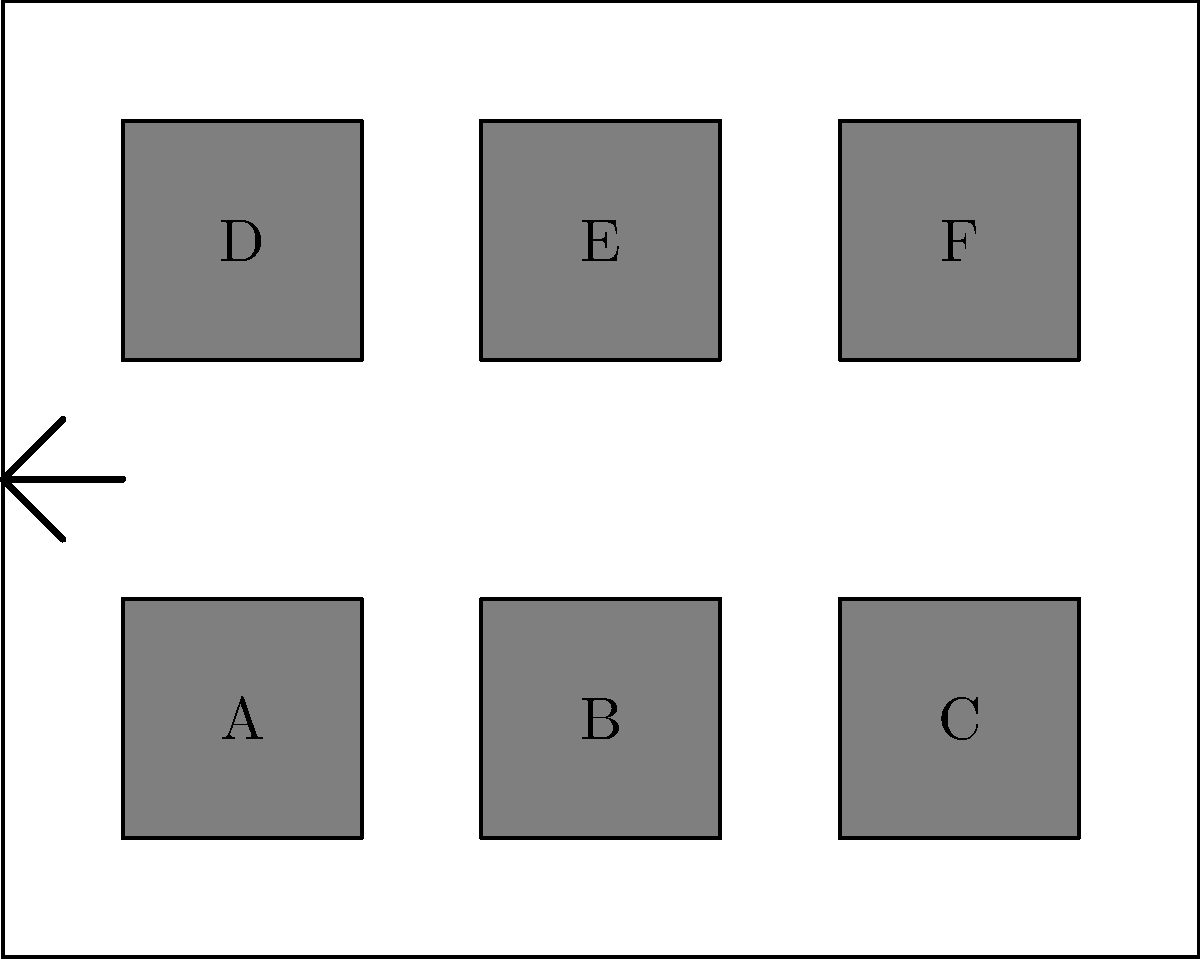In the evidence storage room, boxes are arranged as shown. Each box contains crucial evidence for different cases. To maintain chain of custody, boxes must be moved following strict rules: only one box can be moved at a time, and it must be placed in an empty adjacent space (horizontally or vertically, not diagonally). What is the minimum number of moves required to swap the positions of boxes A and F? To solve this puzzle, we need to find the shortest path to swap boxes A and F while adhering to the given rules. Let's break it down step-by-step:

1. First, we need to create a path from A to F:
   - Move A to the empty space between A and B (1 move)
   - Move B to A's original position (1 move)
   - Move A to B's original position (1 move)
   - Repeat this process until A reaches F's position

2. The path from A to F requires moving through 5 spaces (A → B → C → E → F)

3. For each space traversed, we need 3 moves:
   - Move the box in the target space
   - Move the moving box into the target space
   - Move the displaced box back

4. Total moves for A to reach F's position: $5 \times 3 = 15$ moves

5. After A is in F's position, we need to bring F to A's original position:
   - F can move directly down to C's position (1 move)
   - Then from C to B (3 moves)
   - Finally from B to A's original position (3 moves)

6. Total moves for F to reach A's original position: $1 + 3 + 3 = 7$ moves

7. The total number of moves required: $15 + 7 = 22$ moves

Therefore, the minimum number of moves to swap A and F is 22.
Answer: 22 moves 